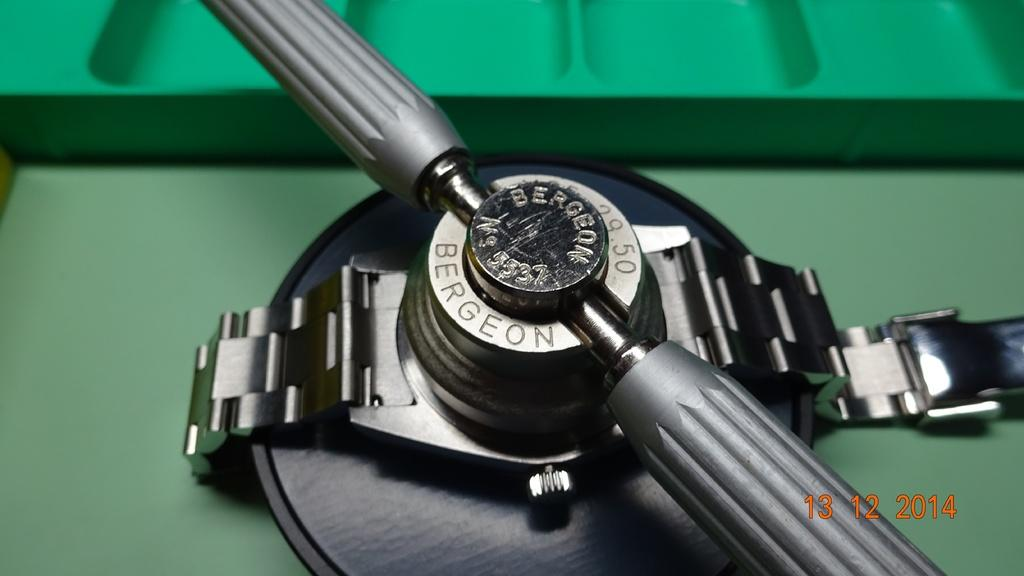<image>
Describe the image concisely. A Berdeon watch is being fixed on a green surface. 